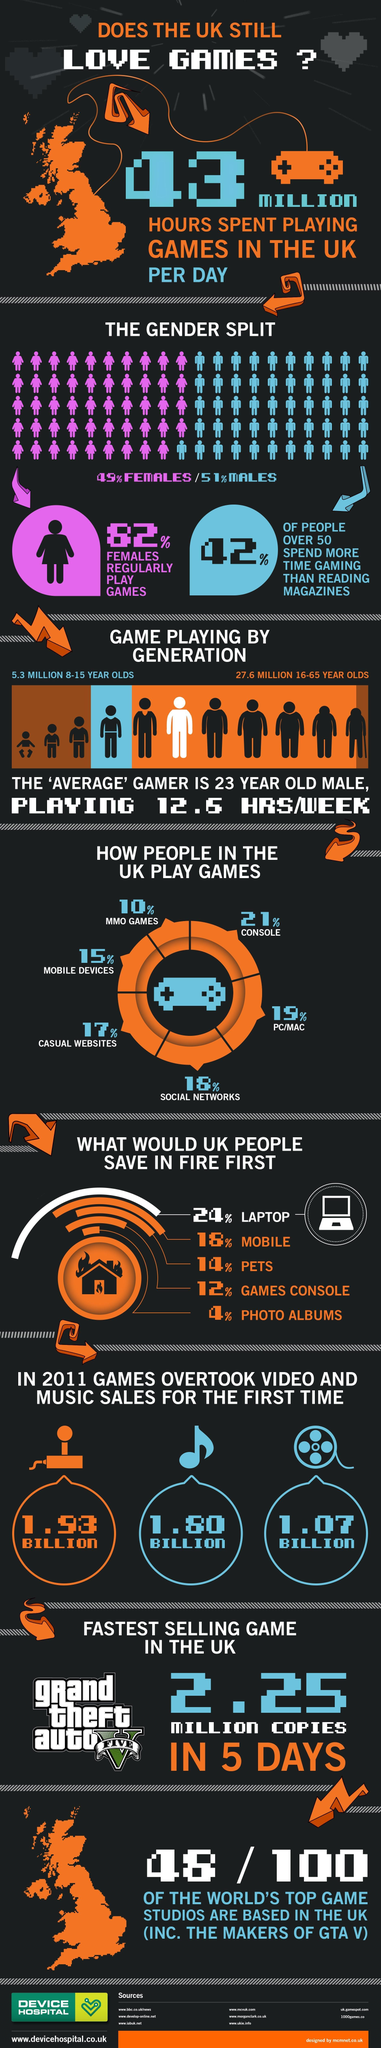What would UK people save in fire third?
Answer the question with a short phrase. pets In 2011, which sold more, games, music or video? games What is the second most used medium to play games? PC/MAC What is the least used medium to play games? MMO games 